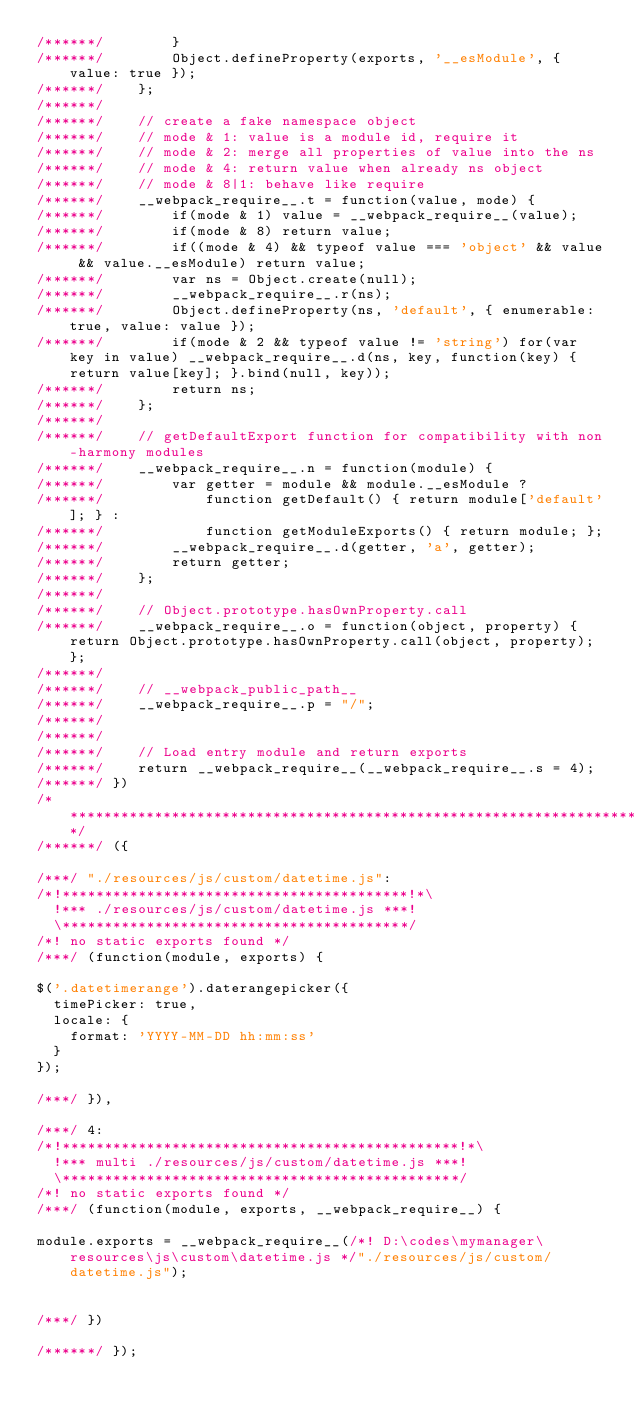Convert code to text. <code><loc_0><loc_0><loc_500><loc_500><_JavaScript_>/******/ 		}
/******/ 		Object.defineProperty(exports, '__esModule', { value: true });
/******/ 	};
/******/
/******/ 	// create a fake namespace object
/******/ 	// mode & 1: value is a module id, require it
/******/ 	// mode & 2: merge all properties of value into the ns
/******/ 	// mode & 4: return value when already ns object
/******/ 	// mode & 8|1: behave like require
/******/ 	__webpack_require__.t = function(value, mode) {
/******/ 		if(mode & 1) value = __webpack_require__(value);
/******/ 		if(mode & 8) return value;
/******/ 		if((mode & 4) && typeof value === 'object' && value && value.__esModule) return value;
/******/ 		var ns = Object.create(null);
/******/ 		__webpack_require__.r(ns);
/******/ 		Object.defineProperty(ns, 'default', { enumerable: true, value: value });
/******/ 		if(mode & 2 && typeof value != 'string') for(var key in value) __webpack_require__.d(ns, key, function(key) { return value[key]; }.bind(null, key));
/******/ 		return ns;
/******/ 	};
/******/
/******/ 	// getDefaultExport function for compatibility with non-harmony modules
/******/ 	__webpack_require__.n = function(module) {
/******/ 		var getter = module && module.__esModule ?
/******/ 			function getDefault() { return module['default']; } :
/******/ 			function getModuleExports() { return module; };
/******/ 		__webpack_require__.d(getter, 'a', getter);
/******/ 		return getter;
/******/ 	};
/******/
/******/ 	// Object.prototype.hasOwnProperty.call
/******/ 	__webpack_require__.o = function(object, property) { return Object.prototype.hasOwnProperty.call(object, property); };
/******/
/******/ 	// __webpack_public_path__
/******/ 	__webpack_require__.p = "/";
/******/
/******/
/******/ 	// Load entry module and return exports
/******/ 	return __webpack_require__(__webpack_require__.s = 4);
/******/ })
/************************************************************************/
/******/ ({

/***/ "./resources/js/custom/datetime.js":
/*!*****************************************!*\
  !*** ./resources/js/custom/datetime.js ***!
  \*****************************************/
/*! no static exports found */
/***/ (function(module, exports) {

$('.datetimerange').daterangepicker({
  timePicker: true,
  locale: {
    format: 'YYYY-MM-DD hh:mm:ss'
  }
});

/***/ }),

/***/ 4:
/*!***********************************************!*\
  !*** multi ./resources/js/custom/datetime.js ***!
  \***********************************************/
/*! no static exports found */
/***/ (function(module, exports, __webpack_require__) {

module.exports = __webpack_require__(/*! D:\codes\mymanager\resources\js\custom\datetime.js */"./resources/js/custom/datetime.js");


/***/ })

/******/ });</code> 